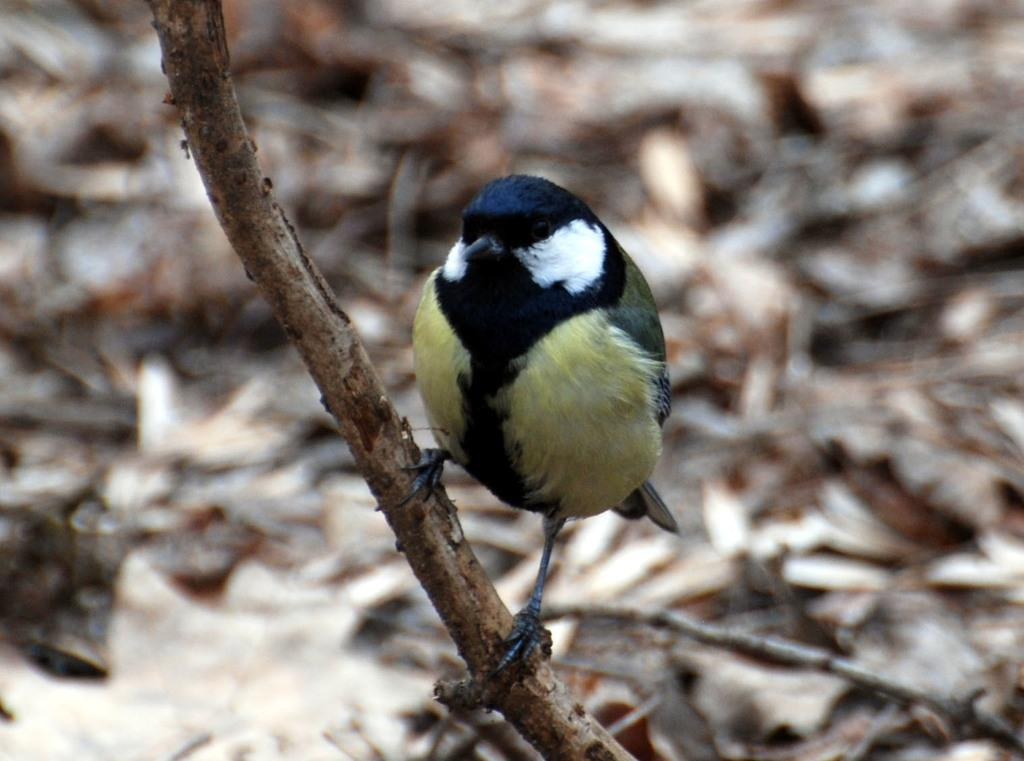What can be seen in the picture that resembles a plant? There is a stem in the picture. What type of animal is present in the picture? There is a bird standing in the picture. What colors can be observed on the bird? The bird has black, yellow, and white coloring. What can be seen in the background of the picture? There is a surface with dried leaves in the background of the picture. What part of the bird is responsible for its ability to fly? The image does not provide information about the bird's ability to fly or the specific body part responsible for it. --- Facts: 1. There is a person sitting on a chair in the image. 2. The person is holding a book. 3. The book has a red cover. 4. There is a table next to the chair. 5. There is a lamp on the table. Absurd Topics: ocean, dance, mountain Conversation: What is the person in the image doing? The person is sitting on a chair in the image. What object is the person holding? The person is holding a book. What color is the book's cover? The book has a red cover. What piece of furniture is next to the chair? There is a table next to the chair. What object is on the table? There is a lamp on the table. Reasoning: Let's think step by step in order to produce the conversation. We start by identifying the main subject in the image, which is the person sitting on a chair. Then, we expand the conversation to include other items that are also visible, such as the book, the table, and the lamp. Each question is designed to elicit a specific detail about the image that is known from the provided facts. Absurd Question/Answer: Can you see any mountains in the background of the image? There are no mountains visible in the image; it only shows a person sitting on a chair, holding a book, and the surrounding furniture. 